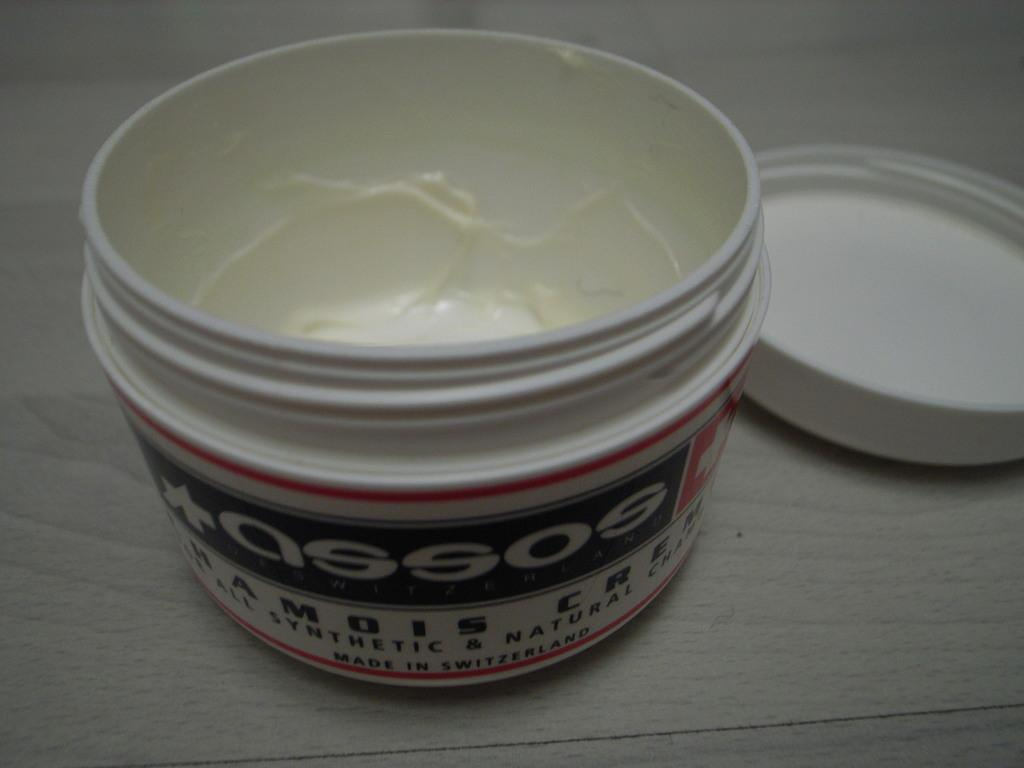Provide a one-sentence caption for the provided image. A jar of  a open cream  made in Switzerland. 